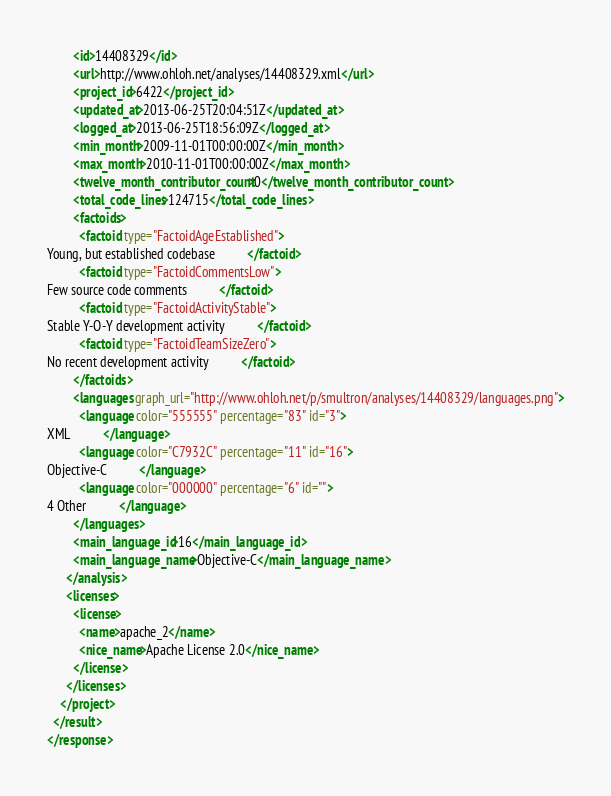Convert code to text. <code><loc_0><loc_0><loc_500><loc_500><_XML_>        <id>14408329</id>
        <url>http://www.ohloh.net/analyses/14408329.xml</url>
        <project_id>6422</project_id>
        <updated_at>2013-06-25T20:04:51Z</updated_at>
        <logged_at>2013-06-25T18:56:09Z</logged_at>
        <min_month>2009-11-01T00:00:00Z</min_month>
        <max_month>2010-11-01T00:00:00Z</max_month>
        <twelve_month_contributor_count>0</twelve_month_contributor_count>
        <total_code_lines>124715</total_code_lines>
        <factoids>
          <factoid type="FactoidAgeEstablished">
Young, but established codebase          </factoid>
          <factoid type="FactoidCommentsLow">
Few source code comments          </factoid>
          <factoid type="FactoidActivityStable">
Stable Y-O-Y development activity          </factoid>
          <factoid type="FactoidTeamSizeZero">
No recent development activity          </factoid>
        </factoids>
        <languages graph_url="http://www.ohloh.net/p/smultron/analyses/14408329/languages.png">
          <language color="555555" percentage="83" id="3">
XML          </language>
          <language color="C7932C" percentage="11" id="16">
Objective-C          </language>
          <language color="000000" percentage="6" id="">
4 Other          </language>
        </languages>
        <main_language_id>16</main_language_id>
        <main_language_name>Objective-C</main_language_name>
      </analysis>
      <licenses>
        <license>
          <name>apache_2</name>
          <nice_name>Apache License 2.0</nice_name>
        </license>
      </licenses>
    </project>
  </result>
</response>
</code> 